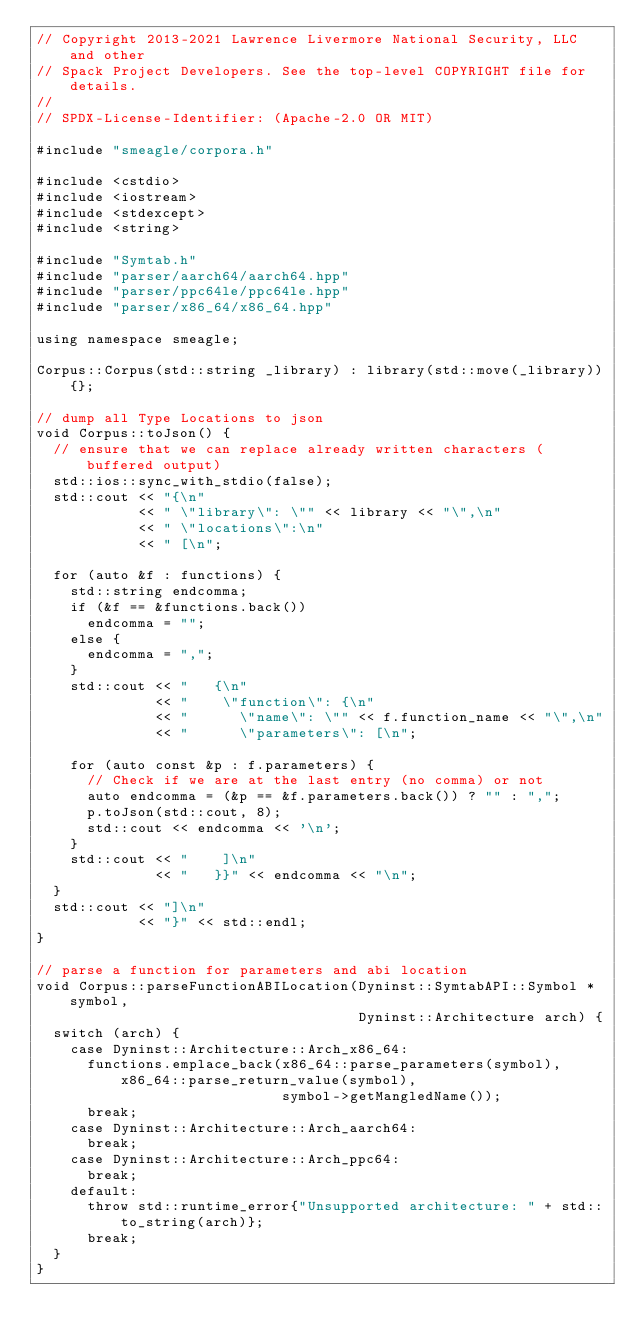Convert code to text. <code><loc_0><loc_0><loc_500><loc_500><_C++_>// Copyright 2013-2021 Lawrence Livermore National Security, LLC and other
// Spack Project Developers. See the top-level COPYRIGHT file for details.
//
// SPDX-License-Identifier: (Apache-2.0 OR MIT)

#include "smeagle/corpora.h"

#include <cstdio>
#include <iostream>
#include <stdexcept>
#include <string>

#include "Symtab.h"
#include "parser/aarch64/aarch64.hpp"
#include "parser/ppc64le/ppc64le.hpp"
#include "parser/x86_64/x86_64.hpp"

using namespace smeagle;

Corpus::Corpus(std::string _library) : library(std::move(_library)){};

// dump all Type Locations to json
void Corpus::toJson() {
  // ensure that we can replace already written characters (buffered output)
  std::ios::sync_with_stdio(false);
  std::cout << "{\n"
            << " \"library\": \"" << library << "\",\n"
            << " \"locations\":\n"
            << " [\n";

  for (auto &f : functions) {
    std::string endcomma;
    if (&f == &functions.back())
      endcomma = "";
    else {
      endcomma = ",";
    }
    std::cout << "   {\n"
              << "    \"function\": {\n"
              << "      \"name\": \"" << f.function_name << "\",\n"
              << "      \"parameters\": [\n";

    for (auto const &p : f.parameters) {
      // Check if we are at the last entry (no comma) or not
      auto endcomma = (&p == &f.parameters.back()) ? "" : ",";
      p.toJson(std::cout, 8);
      std::cout << endcomma << '\n';
    }
    std::cout << "    ]\n"
              << "   }}" << endcomma << "\n";
  }
  std::cout << "]\n"
            << "}" << std::endl;
}

// parse a function for parameters and abi location
void Corpus::parseFunctionABILocation(Dyninst::SymtabAPI::Symbol *symbol,
                                      Dyninst::Architecture arch) {
  switch (arch) {
    case Dyninst::Architecture::Arch_x86_64:
      functions.emplace_back(x86_64::parse_parameters(symbol), x86_64::parse_return_value(symbol),
                             symbol->getMangledName());
      break;
    case Dyninst::Architecture::Arch_aarch64:
      break;
    case Dyninst::Architecture::Arch_ppc64:
      break;
    default:
      throw std::runtime_error{"Unsupported architecture: " + std::to_string(arch)};
      break;
  }
}
</code> 